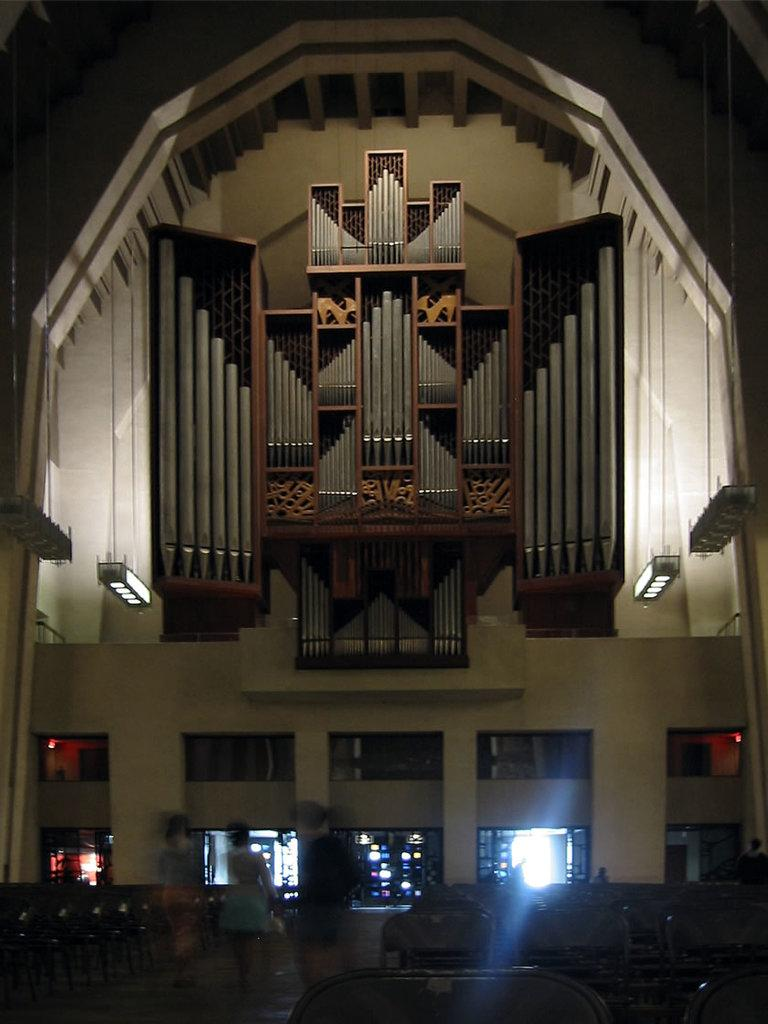What type of structure is visible in the image? There is a wall in the image. What can be seen illuminating the area in the image? There are lights in the image. Are there any openings in the wall visible in the image? Yes, there are windows in the image. Can you describe the person in the image? There is a person in the image. How would you characterize the lighting conditions in the image? The image is described as being a little dark. What is the name of the daughter in the image? There is no daughter present in the image. How many boys can be seen playing in the image? There are no boys visible in the image. 